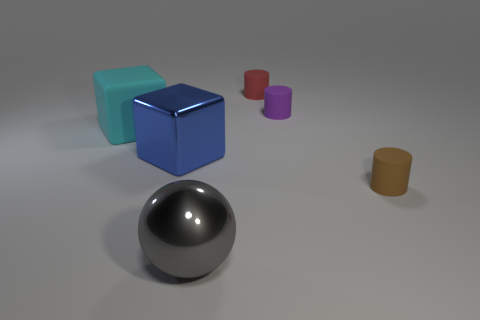What number of small red rubber things are the same shape as the large cyan thing?
Provide a succinct answer. 0. Do the tiny red cylinder and the object in front of the tiny brown rubber cylinder have the same material?
Make the answer very short. No. What material is the block that is the same size as the cyan rubber object?
Provide a succinct answer. Metal. Is there a metal cube of the same size as the red object?
Give a very brief answer. No. The shiny thing that is the same size as the metallic block is what shape?
Ensure brevity in your answer.  Sphere. How many other objects are there of the same color as the large metal sphere?
Keep it short and to the point. 0. The matte object that is on the right side of the large blue object and on the left side of the small purple cylinder has what shape?
Make the answer very short. Cylinder. There is a object in front of the cylinder that is in front of the big rubber thing; is there a large gray shiny ball in front of it?
Your answer should be very brief. No. How many other things are there of the same material as the big blue block?
Ensure brevity in your answer.  1. How many metal objects are there?
Your answer should be compact. 2. 